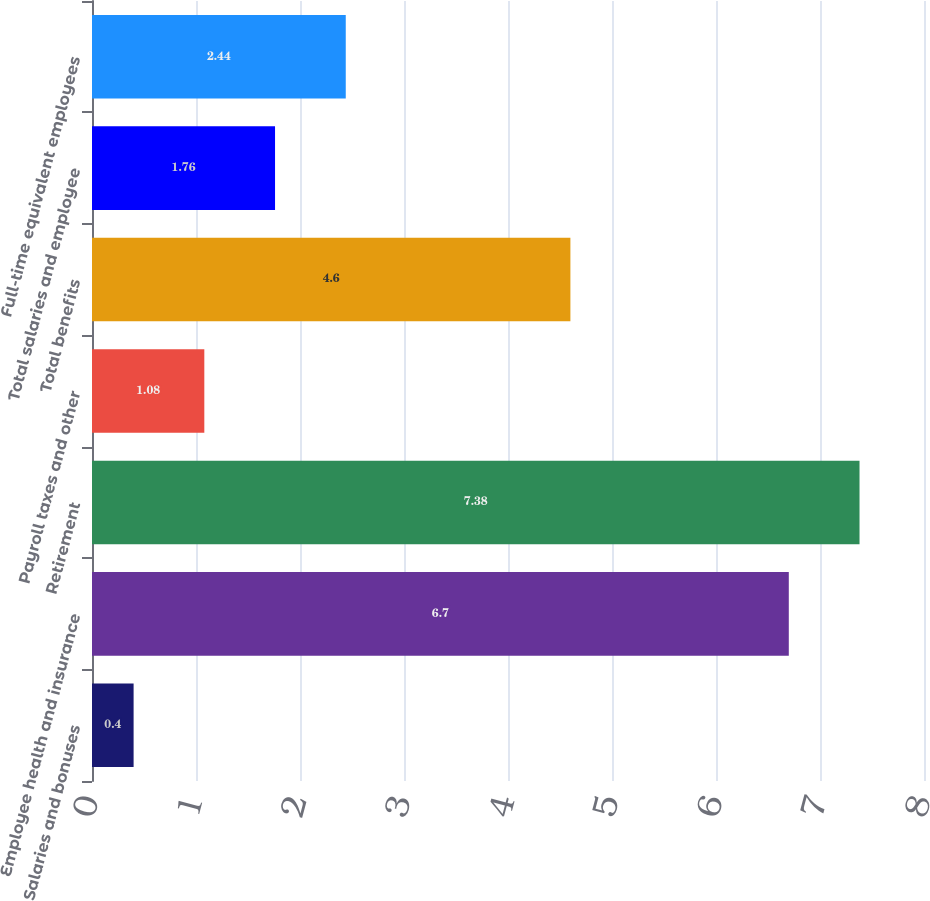<chart> <loc_0><loc_0><loc_500><loc_500><bar_chart><fcel>Salaries and bonuses<fcel>Employee health and insurance<fcel>Retirement<fcel>Payroll taxes and other<fcel>Total benefits<fcel>Total salaries and employee<fcel>Full-time equivalent employees<nl><fcel>0.4<fcel>6.7<fcel>7.38<fcel>1.08<fcel>4.6<fcel>1.76<fcel>2.44<nl></chart> 